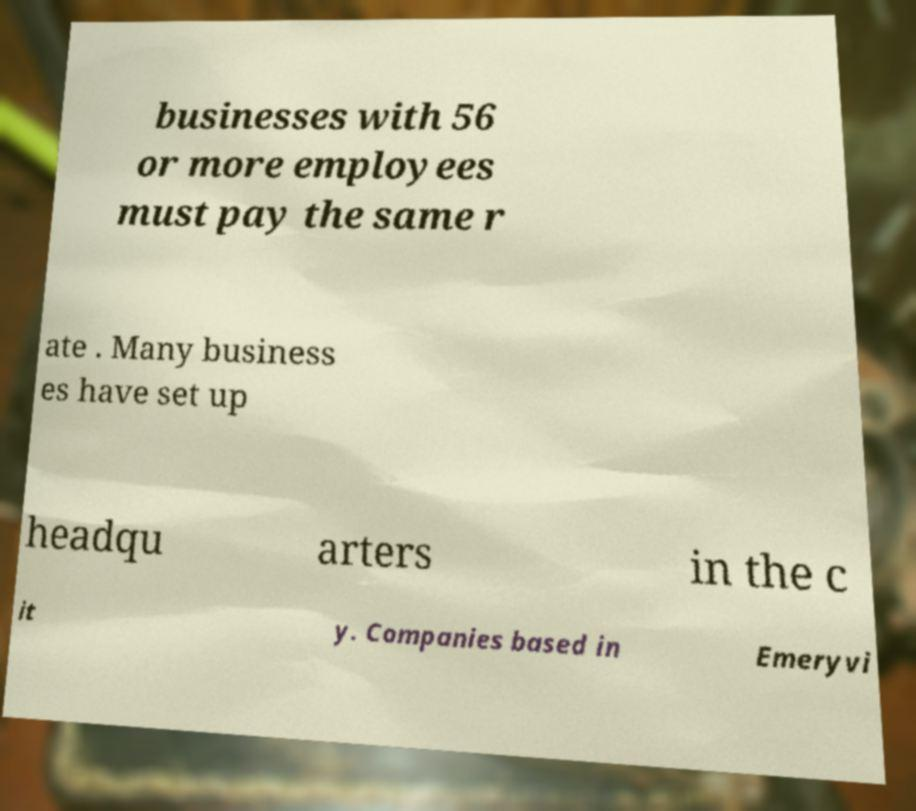Could you extract and type out the text from this image? businesses with 56 or more employees must pay the same r ate . Many business es have set up headqu arters in the c it y. Companies based in Emeryvi 